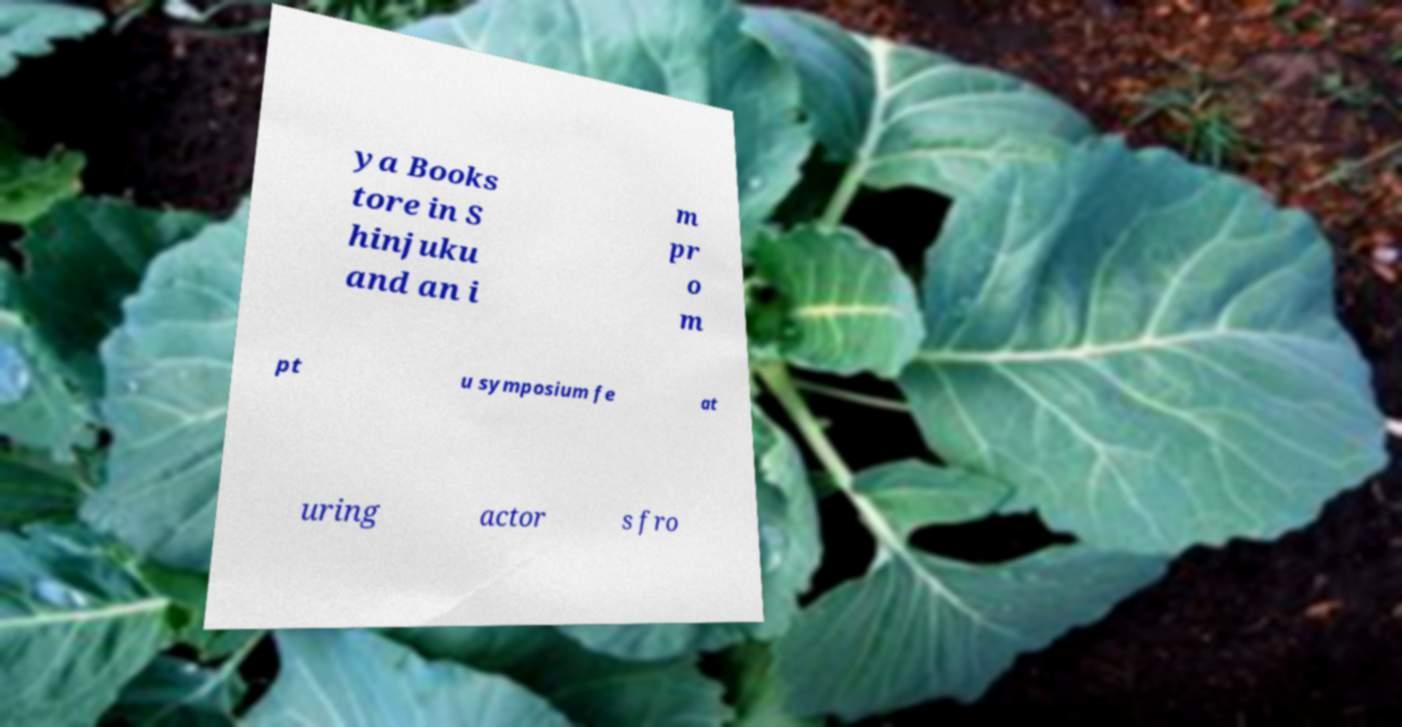What messages or text are displayed in this image? I need them in a readable, typed format. ya Books tore in S hinjuku and an i m pr o m pt u symposium fe at uring actor s fro 